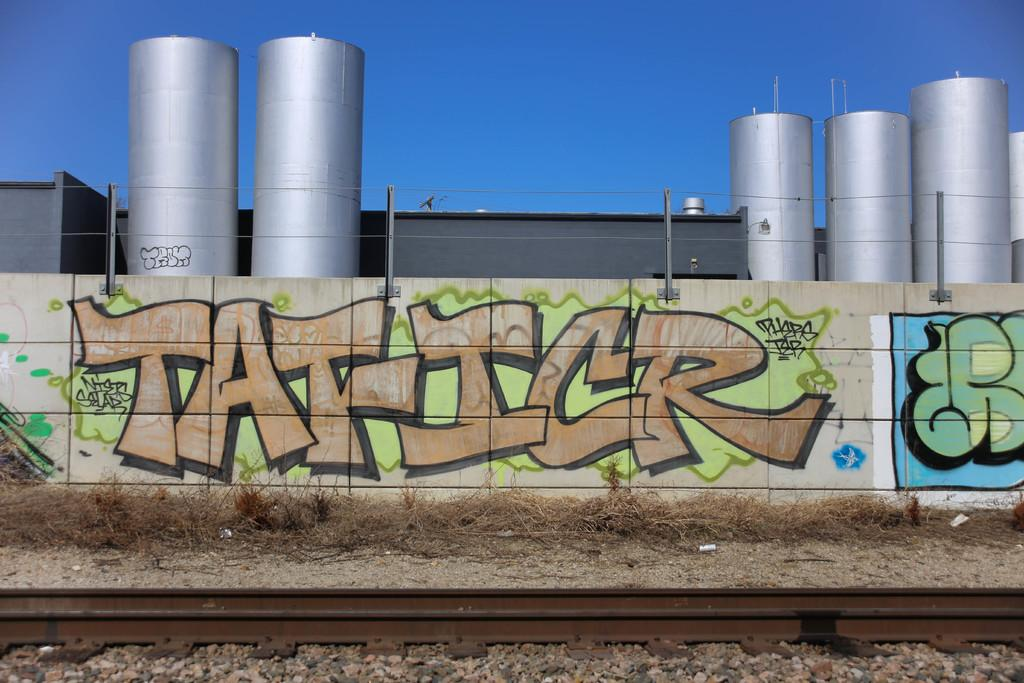<image>
Relay a brief, clear account of the picture shown. Graffiti on an outdoor concrete wall says, "Tat-ICR" 